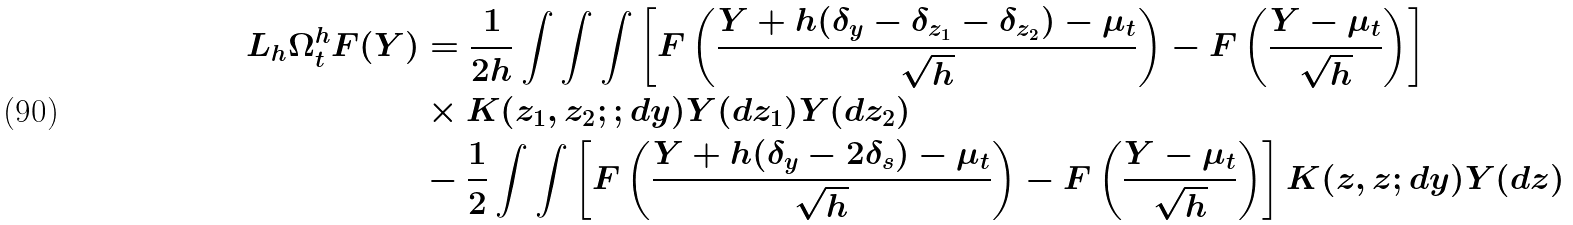<formula> <loc_0><loc_0><loc_500><loc_500>L _ { h } \Omega ^ { h } _ { t } F ( Y ) & = \frac { 1 } { 2 h } \int \int \int \left [ F \left ( \frac { Y + h ( \delta _ { y } - \delta _ { z _ { 1 } } - \delta _ { z _ { 2 } } ) - \mu _ { t } } { \sqrt { h } } \right ) - F \left ( \frac { Y - \mu _ { t } } { \sqrt { h } } \right ) \right ] \\ & \times K ( z _ { 1 } , z _ { 2 } ; ; d y ) Y ( d z _ { 1 } ) Y ( d z _ { 2 } ) \\ & - \frac { 1 } { 2 } \int \int \left [ F \left ( \frac { Y + h ( \delta _ { y } - 2 \delta _ { s } ) - \mu _ { t } } { \sqrt { h } } \right ) - F \left ( \frac { Y - \mu _ { t } } { \sqrt { h } } \right ) \right ] K ( z , z ; d y ) Y ( d z )</formula> 